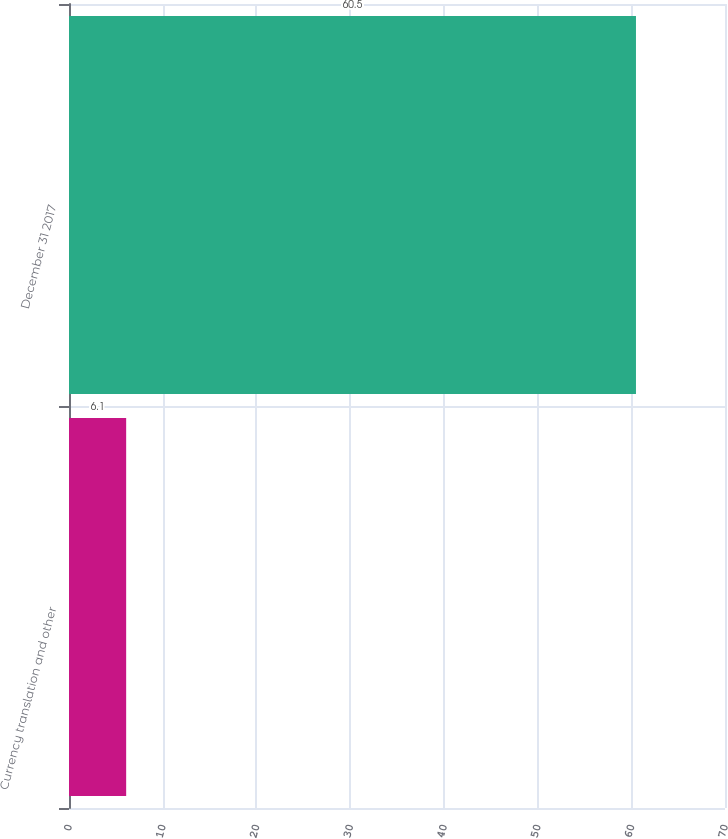Convert chart. <chart><loc_0><loc_0><loc_500><loc_500><bar_chart><fcel>Currency translation and other<fcel>December 31 2017<nl><fcel>6.1<fcel>60.5<nl></chart> 